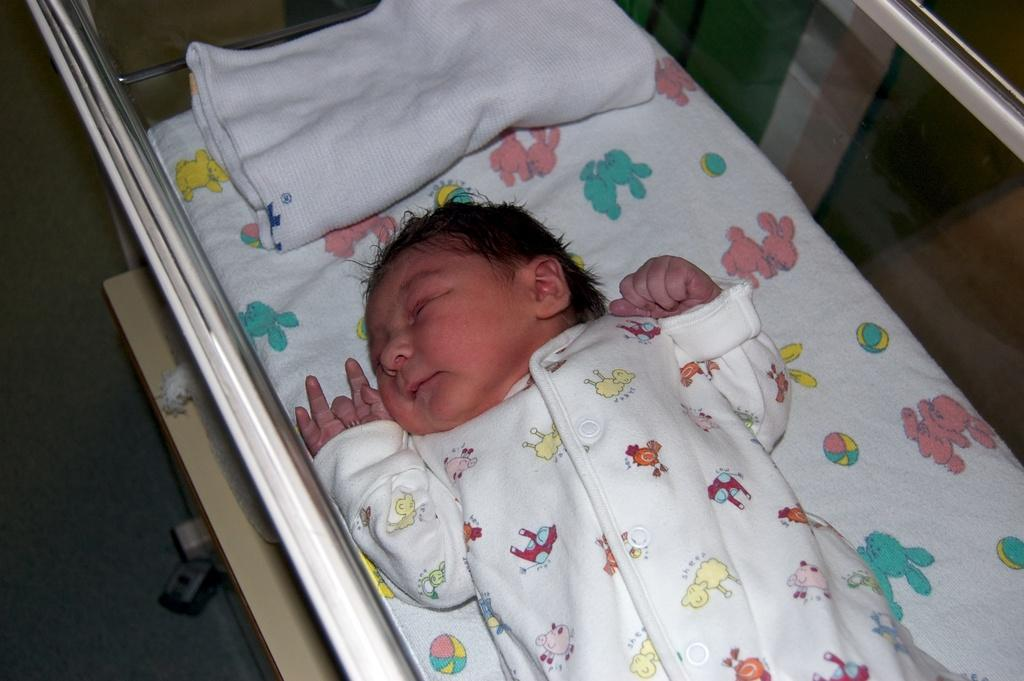What is the main subject of the image? There is a baby in the image. Where is the baby located? The baby is in a bed. What type of surface is visible in the image? There is a floor visible in the image. Can you describe any other objects in the image? There is a wheel in the image. What type of receipt can be seen in the baby's hand in the image? There is no receipt present in the image, and the baby does not have any objects in their hand. 